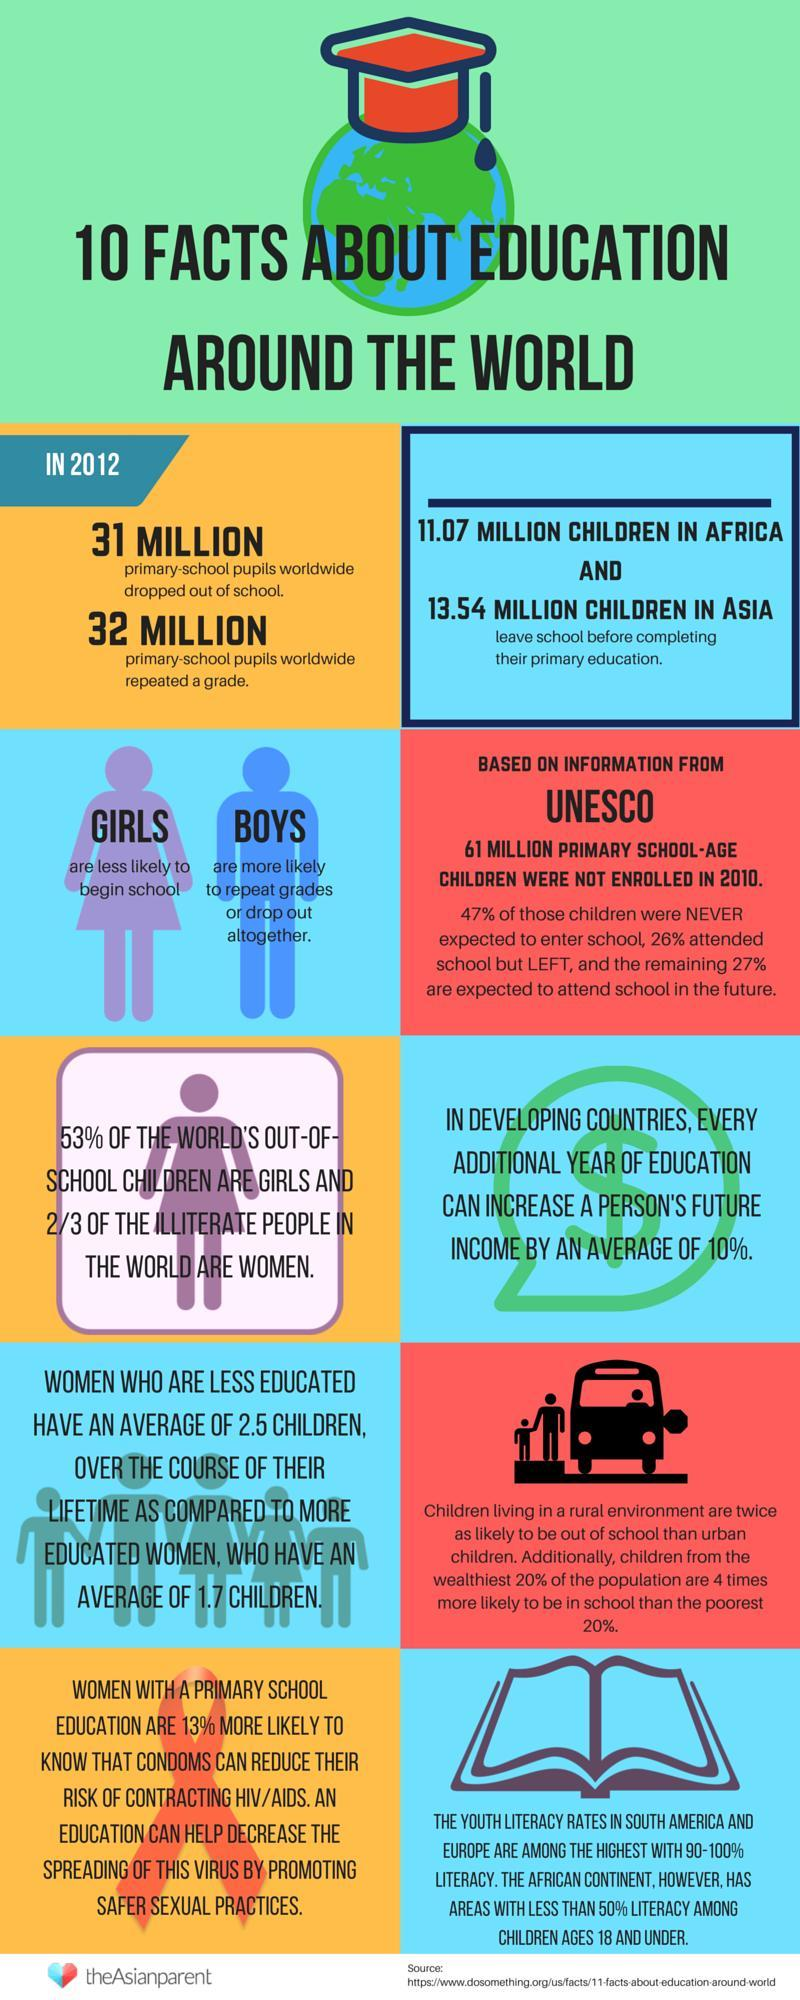What is the difference in average of children that less educated women have in comparison to educated women ?
Answer the question with a short phrase. 0.8 Which two continents have highest literacy rates among youths ? South America and Europe 